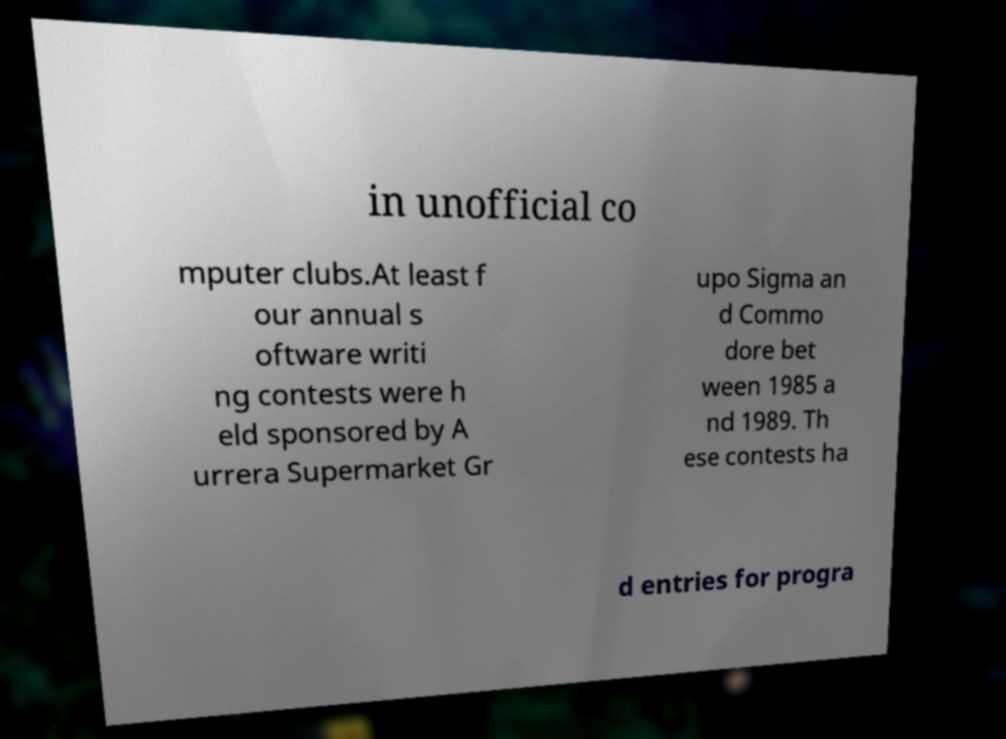Please identify and transcribe the text found in this image. in unofficial co mputer clubs.At least f our annual s oftware writi ng contests were h eld sponsored by A urrera Supermarket Gr upo Sigma an d Commo dore bet ween 1985 a nd 1989. Th ese contests ha d entries for progra 